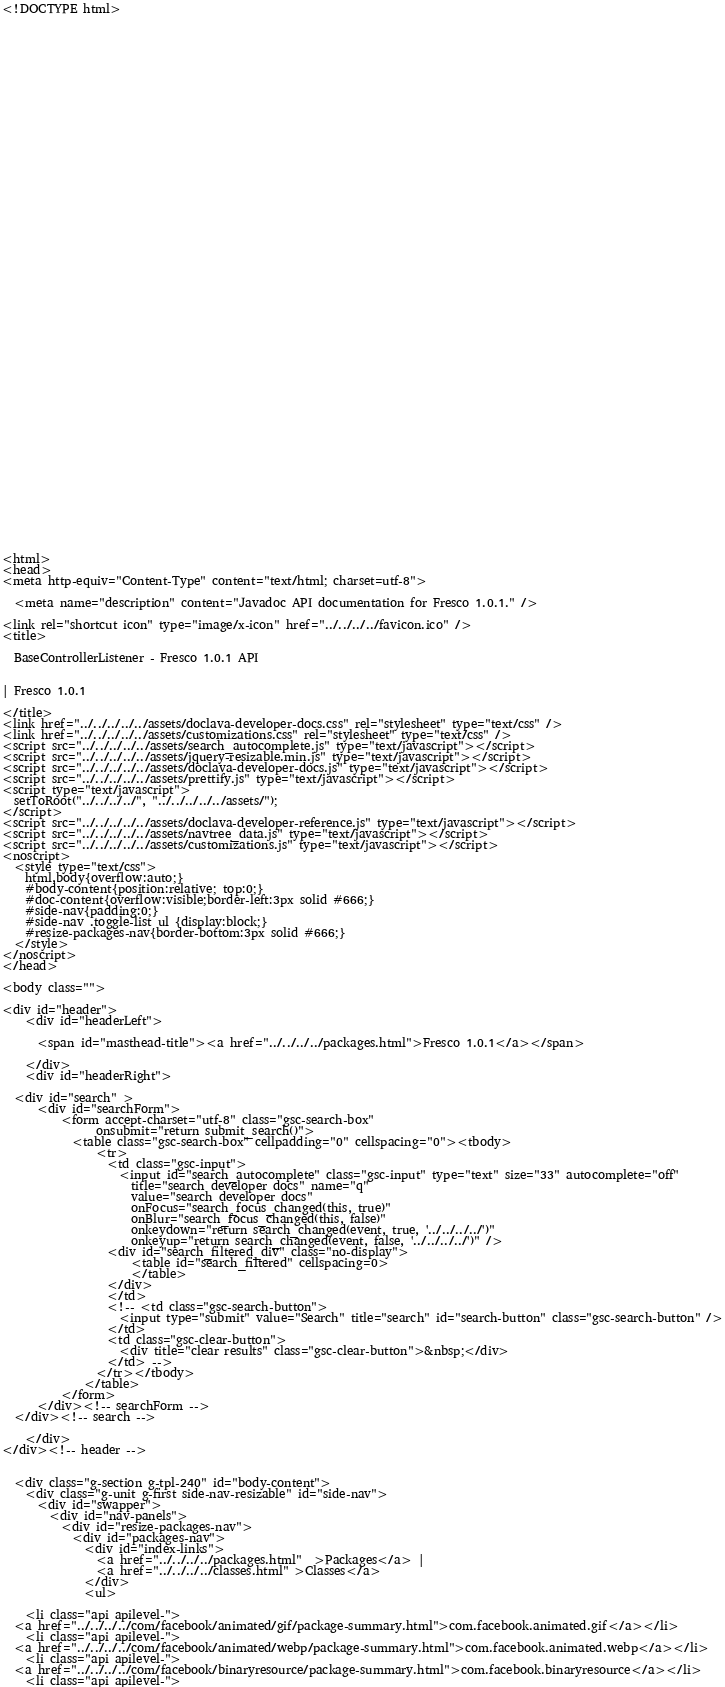<code> <loc_0><loc_0><loc_500><loc_500><_HTML_><!DOCTYPE html>

















































<html>
<head>
<meta http-equiv="Content-Type" content="text/html; charset=utf-8">

  <meta name="description" content="Javadoc API documentation for Fresco 1.0.1." />

<link rel="shortcut icon" type="image/x-icon" href="../../../../favicon.ico" />
<title>

  BaseControllerListener - Fresco 1.0.1 API


| Fresco 1.0.1

</title>
<link href="../../../../../assets/doclava-developer-docs.css" rel="stylesheet" type="text/css" />
<link href="../../../../../assets/customizations.css" rel="stylesheet" type="text/css" />
<script src="../../../../../assets/search_autocomplete.js" type="text/javascript"></script>
<script src="../../../../../assets/jquery-resizable.min.js" type="text/javascript"></script>
<script src="../../../../../assets/doclava-developer-docs.js" type="text/javascript"></script>
<script src="../../../../../assets/prettify.js" type="text/javascript"></script>
<script type="text/javascript">
  setToRoot("../../../../", "../../../../../assets/");
</script>
<script src="../../../../../assets/doclava-developer-reference.js" type="text/javascript"></script>
<script src="../../../../../assets/navtree_data.js" type="text/javascript"></script>
<script src="../../../../../assets/customizations.js" type="text/javascript"></script>
<noscript>
  <style type="text/css">
    html,body{overflow:auto;}
    #body-content{position:relative; top:0;}
    #doc-content{overflow:visible;border-left:3px solid #666;}
    #side-nav{padding:0;}
    #side-nav .toggle-list ul {display:block;}
    #resize-packages-nav{border-bottom:3px solid #666;}
  </style>
</noscript>
</head>

<body class="">

<div id="header">
    <div id="headerLeft">
    
      <span id="masthead-title"><a href="../../../../packages.html">Fresco 1.0.1</a></span>
    
    </div>
    <div id="headerRight">
      
  <div id="search" >
      <div id="searchForm">
          <form accept-charset="utf-8" class="gsc-search-box" 
                onsubmit="return submit_search()">
            <table class="gsc-search-box" cellpadding="0" cellspacing="0"><tbody>
                <tr>
                  <td class="gsc-input">
                    <input id="search_autocomplete" class="gsc-input" type="text" size="33" autocomplete="off"
                      title="search developer docs" name="q"
                      value="search developer docs"
                      onFocus="search_focus_changed(this, true)"
                      onBlur="search_focus_changed(this, false)"
                      onkeydown="return search_changed(event, true, '../../../../')"
                      onkeyup="return search_changed(event, false, '../../../../')" />
                  <div id="search_filtered_div" class="no-display">
                      <table id="search_filtered" cellspacing=0>
                      </table>
                  </div>
                  </td>
                  <!-- <td class="gsc-search-button">
                    <input type="submit" value="Search" title="search" id="search-button" class="gsc-search-button" />
                  </td>
                  <td class="gsc-clear-button">
                    <div title="clear results" class="gsc-clear-button">&nbsp;</div>
                  </td> -->
                </tr></tbody>
              </table>
          </form>
      </div><!-- searchForm -->
  </div><!-- search -->
      
    </div>
</div><!-- header -->


  <div class="g-section g-tpl-240" id="body-content">
    <div class="g-unit g-first side-nav-resizable" id="side-nav">
      <div id="swapper">
        <div id="nav-panels">
          <div id="resize-packages-nav">
            <div id="packages-nav">
              <div id="index-links">
                <a href="../../../../packages.html"  >Packages</a> | 
                <a href="../../../../classes.html" >Classes</a>
              </div>
              <ul>
                
    <li class="api apilevel-">
  <a href="../../../../com/facebook/animated/gif/package-summary.html">com.facebook.animated.gif</a></li>
    <li class="api apilevel-">
  <a href="../../../../com/facebook/animated/webp/package-summary.html">com.facebook.animated.webp</a></li>
    <li class="api apilevel-">
  <a href="../../../../com/facebook/binaryresource/package-summary.html">com.facebook.binaryresource</a></li>
    <li class="api apilevel-"></code> 